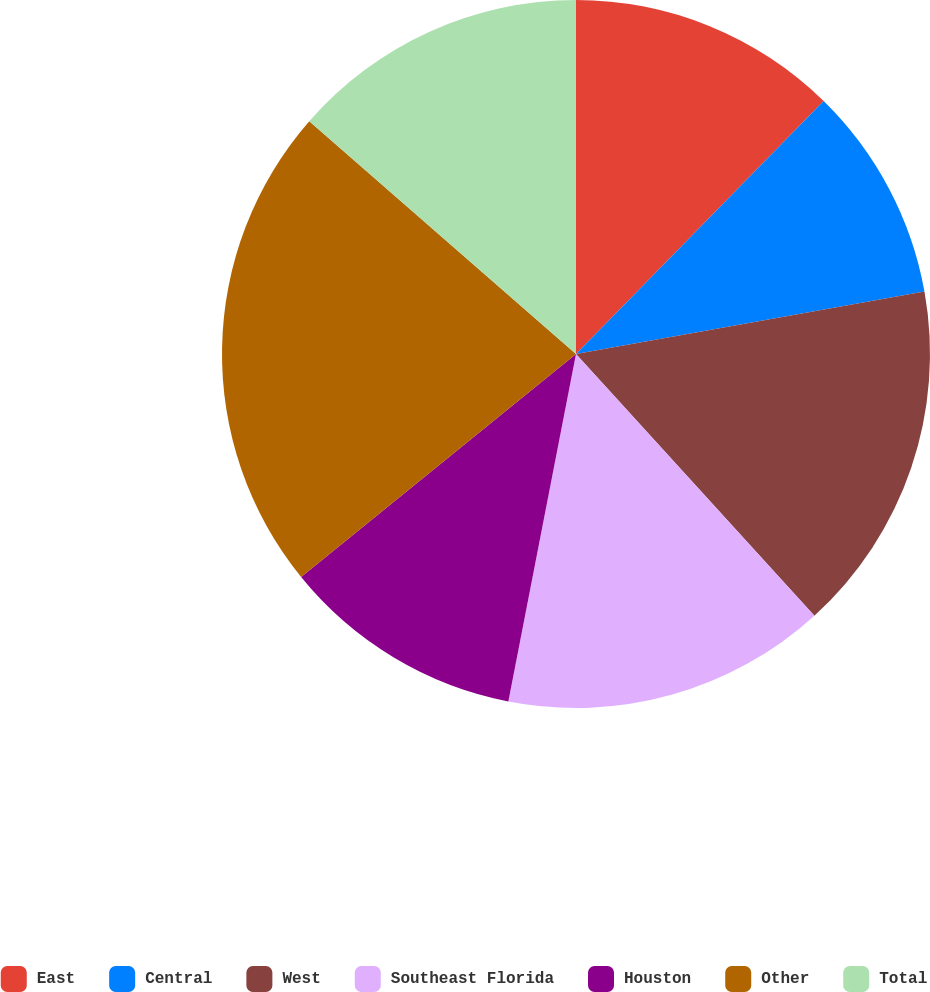Convert chart. <chart><loc_0><loc_0><loc_500><loc_500><pie_chart><fcel>East<fcel>Central<fcel>West<fcel>Southeast Florida<fcel>Houston<fcel>Other<fcel>Total<nl><fcel>12.33%<fcel>9.85%<fcel>16.06%<fcel>14.82%<fcel>11.09%<fcel>22.27%<fcel>13.58%<nl></chart> 